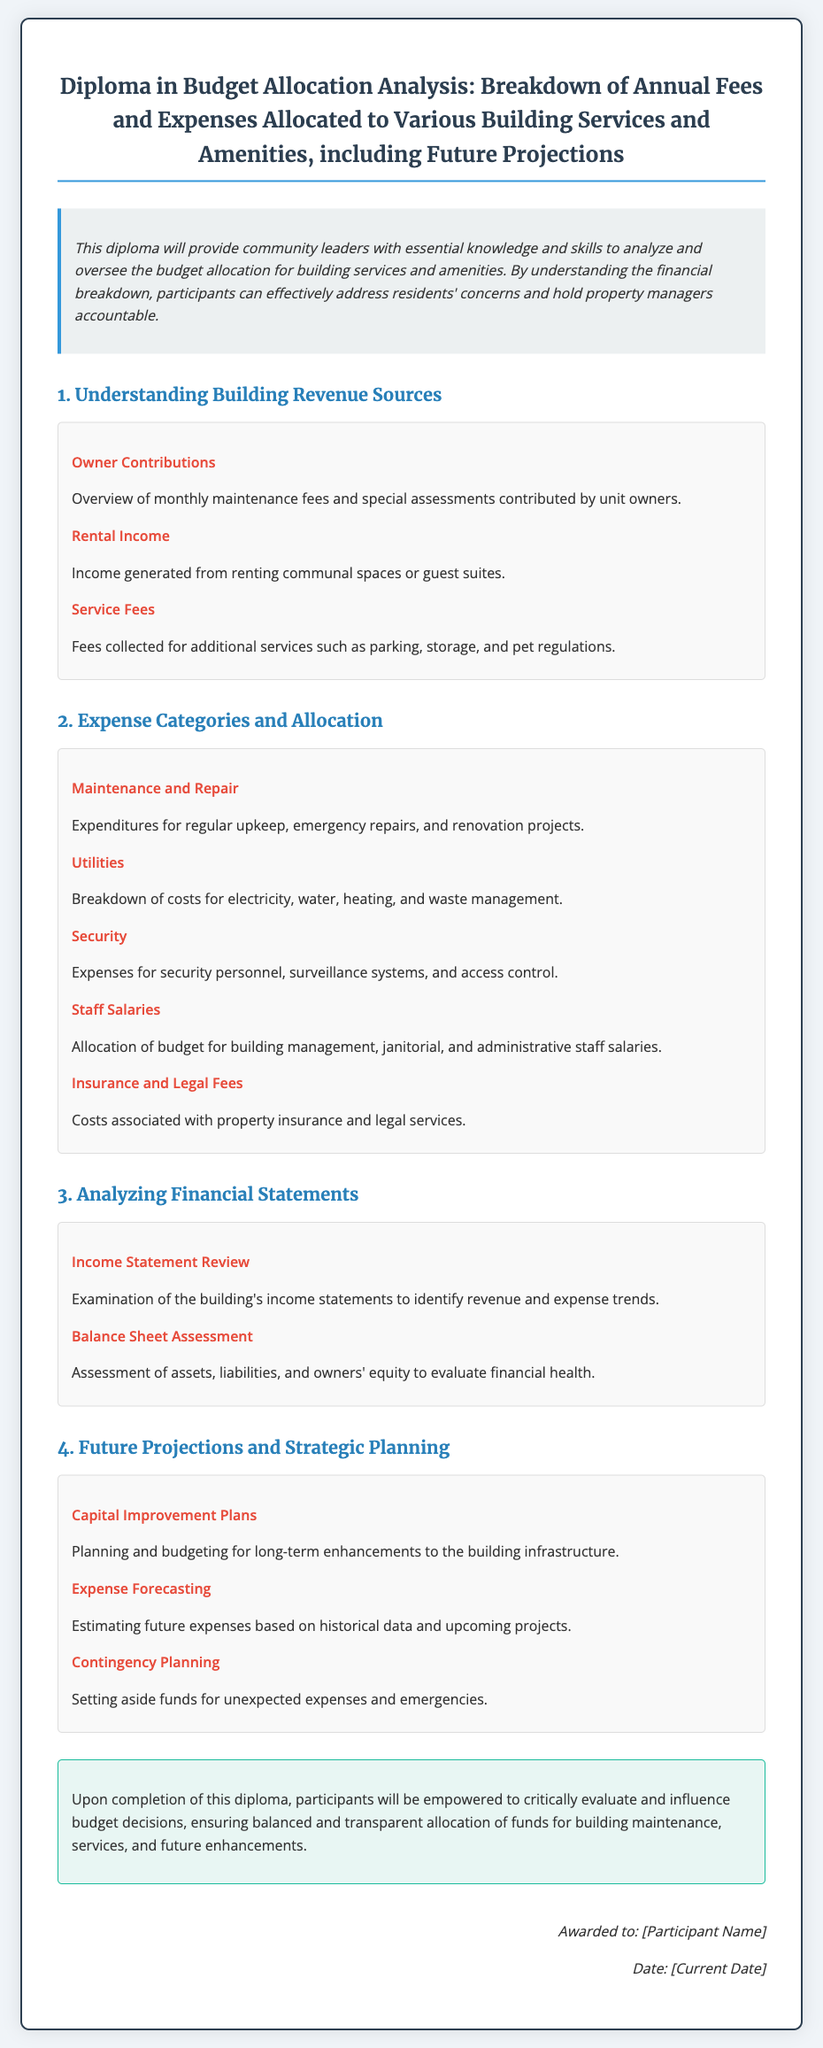What is the title of the diploma? The title of the diploma can be found at the top of the document, stating the course name.
Answer: Diploma in Budget Allocation Analysis: Breakdown of Annual Fees and Expenses Allocated to Various Building Services and Amenities, including Future Projections What is included in Section 2 of the diploma? Section 2 outlines the categories of expenses and their allocation as listed in the document.
Answer: Expense Categories and Allocation What are the components of Owner Contributions? The description under Owner Contributions specifies what contributes to this revenue source.
Answer: Monthly maintenance fees and special assessments What does the conclusion summarize? The conclusion section summarizes the overall goals and outcomes of completing the diploma.
Answer: Empower participants to critically evaluate and influence budget decisions What is one purpose of Capital Improvement Plans? The document indicates a key purpose associated with long-term building enhancements.
Answer: Long-term enhancements to the building infrastructure What type of planning does the diploma emphasize for unexpected costs? The section on Future Projections indicates the importance of planning for unanticipated expenses.
Answer: Contingency Planning How many modules are in the diploma? The document clearly lists each module and their respective titles; counting them gives the answer.
Answer: Four What font is used for the headings? The document specifies the font used for headings in its style section.
Answer: Merriweather What does the module titled "Analyzing Financial Statements" focus on? This module provides insights into evaluating specific financial documents within the budget context.
Answer: Income Statement Review and Balance Sheet Assessment 